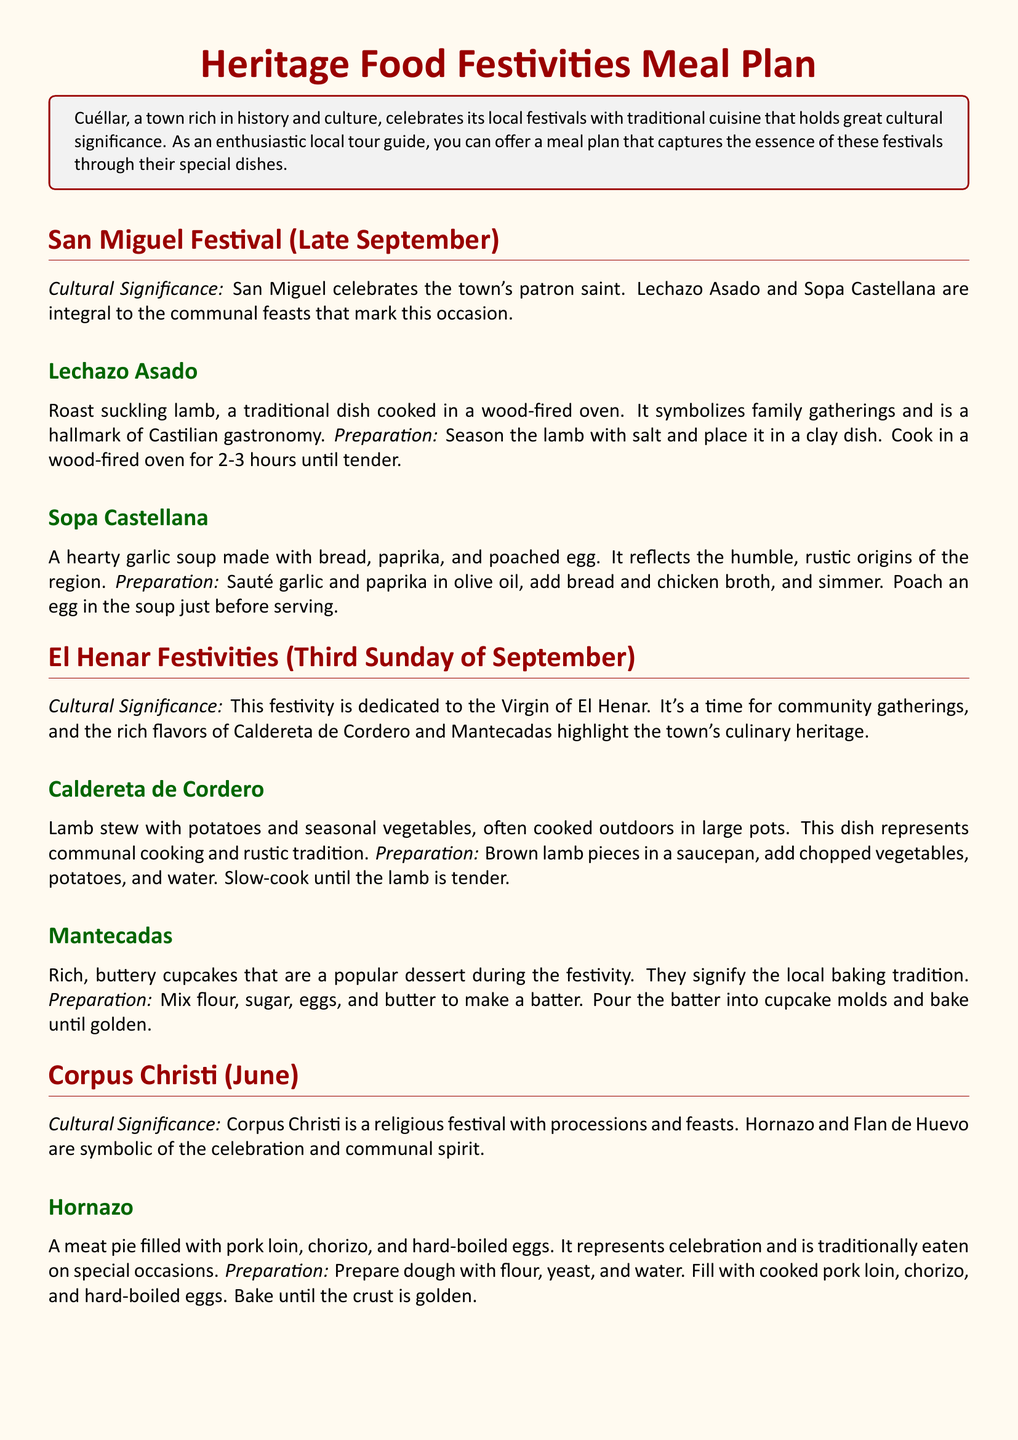What is celebrated during San Miguel Festival? The San Miguel Festival celebrates the town's patron saint.
Answer: patron saint What dish is made with suckling lamb? The dish made with suckling lamb during the San Miguel Festival is Lechazo Asado.
Answer: Lechazo Asado What is the preparation time for Lechazo Asado? The preparation time for Lechazo Asado is 2-3 hours until tender.
Answer: 2-3 hours What type of soup is Sopa Castellana? Sopa Castellana is a hearty garlic soup.
Answer: hearty garlic soup What is the main ingredient in Hornazo? The main ingredient in Hornazo is pork loin.
Answer: pork loin Which festivity highlights Caldereta de Cordero? El Henar Festivities highlight Caldereta de Cordero.
Answer: El Henar Festivities What dessert is mentioned along with Mantecadas? The dessert mentioned along with Mantecadas is Flan de Huevo.
Answer: Flan de Huevo What does Corpus Christi represent? Corpus Christi is a religious festival.
Answer: religious festival What signifies local baking tradition? Mantecadas signify the local baking tradition.
Answer: Mantecadas 